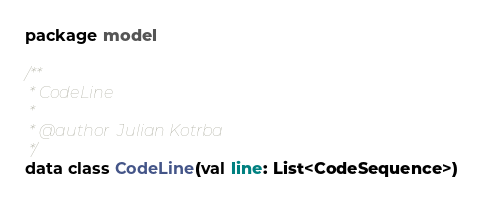Convert code to text. <code><loc_0><loc_0><loc_500><loc_500><_Kotlin_>package model

/**
 * CodeLine
 *
 * @author  Julian Kotrba
 */
data class CodeLine(val line: List<CodeSequence>)</code> 